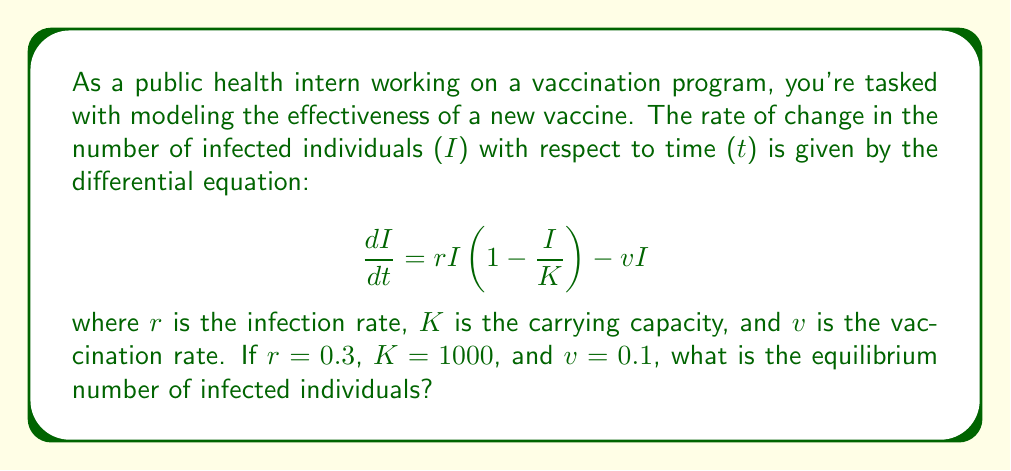Can you answer this question? To find the equilibrium number of infected individuals, we need to set the rate of change to zero and solve for I:

1) Set $\frac{dI}{dt} = 0$:
   $$0 = rI(1-\frac{I}{K}) - vI$$

2) Substitute the given values:
   $$0 = 0.3I(1-\frac{I}{1000}) - 0.1I$$

3) Expand the equation:
   $$0 = 0.3I - 0.0003I^2 - 0.1I$$

4) Simplify:
   $$0 = 0.2I - 0.0003I^2$$

5) Factor out I:
   $$0 = I(0.2 - 0.0003I)$$

6) Solve for I:
   Either $I = 0$ or $0.2 - 0.0003I = 0$
   
   From the second equation:
   $$0.2 = 0.0003I$$
   $$I = \frac{0.2}{0.0003} = 666.67$$

7) The non-zero solution is the stable equilibrium:
   $$I \approx 667$$ (rounded to the nearest whole number)
Answer: 667 infected individuals 